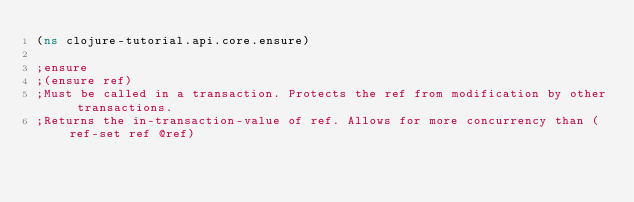Convert code to text. <code><loc_0><loc_0><loc_500><loc_500><_Clojure_>(ns clojure-tutorial.api.core.ensure)

;ensure
;(ensure ref)
;Must be called in a transaction. Protects the ref from modification by other transactions.
;Returns the in-transaction-value of ref. Allows for more concurrency than (ref-set ref @ref)</code> 